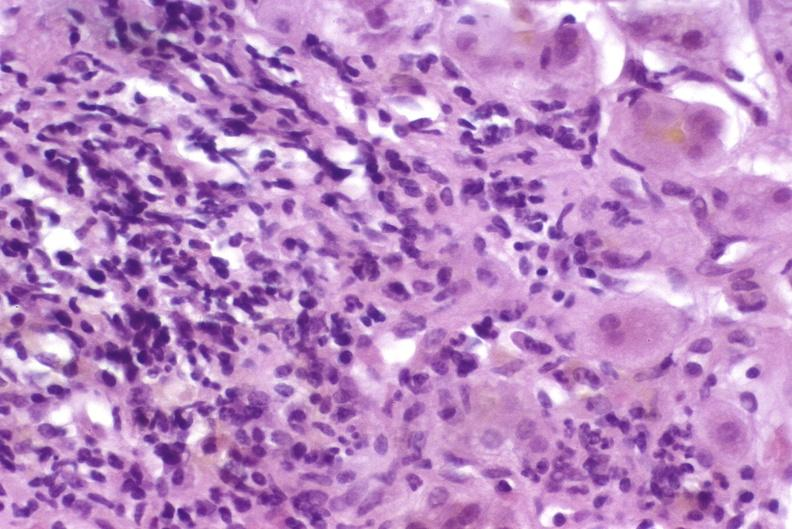does this image show autoimmune hepatitis?
Answer the question using a single word or phrase. Yes 